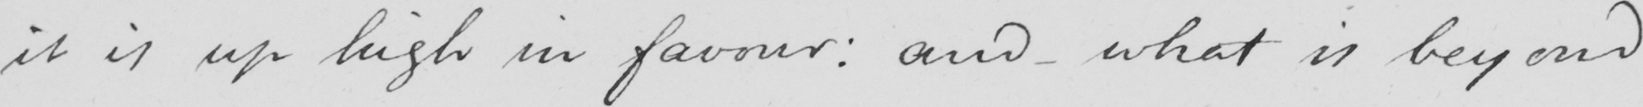What does this handwritten line say? it is up high in favour :  and - what is beyond 